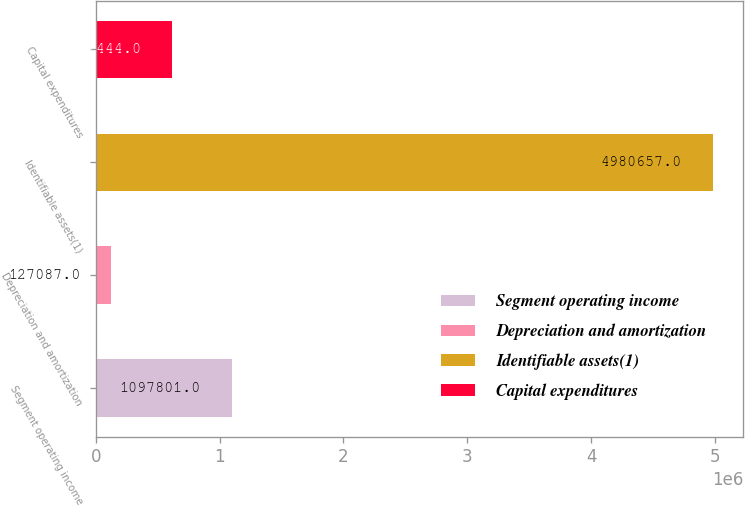Convert chart to OTSL. <chart><loc_0><loc_0><loc_500><loc_500><bar_chart><fcel>Segment operating income<fcel>Depreciation and amortization<fcel>Identifiable assets(1)<fcel>Capital expenditures<nl><fcel>1.0978e+06<fcel>127087<fcel>4.98066e+06<fcel>612444<nl></chart> 